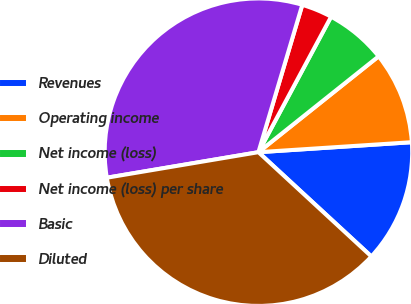<chart> <loc_0><loc_0><loc_500><loc_500><pie_chart><fcel>Revenues<fcel>Operating income<fcel>Net income (loss)<fcel>Net income (loss) per share<fcel>Basic<fcel>Diluted<nl><fcel>12.9%<fcel>9.68%<fcel>6.45%<fcel>3.23%<fcel>32.26%<fcel>35.48%<nl></chart> 